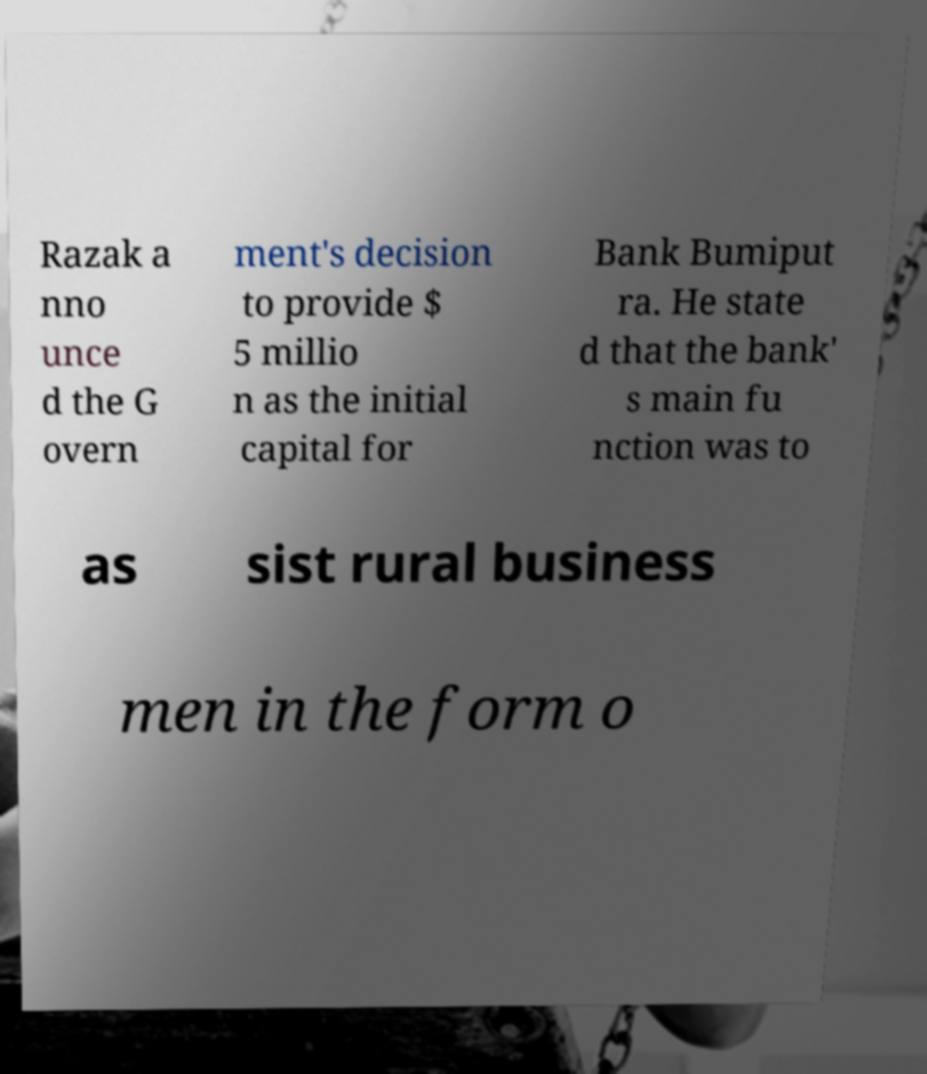I need the written content from this picture converted into text. Can you do that? Razak a nno unce d the G overn ment's decision to provide $ 5 millio n as the initial capital for Bank Bumiput ra. He state d that the bank' s main fu nction was to as sist rural business men in the form o 